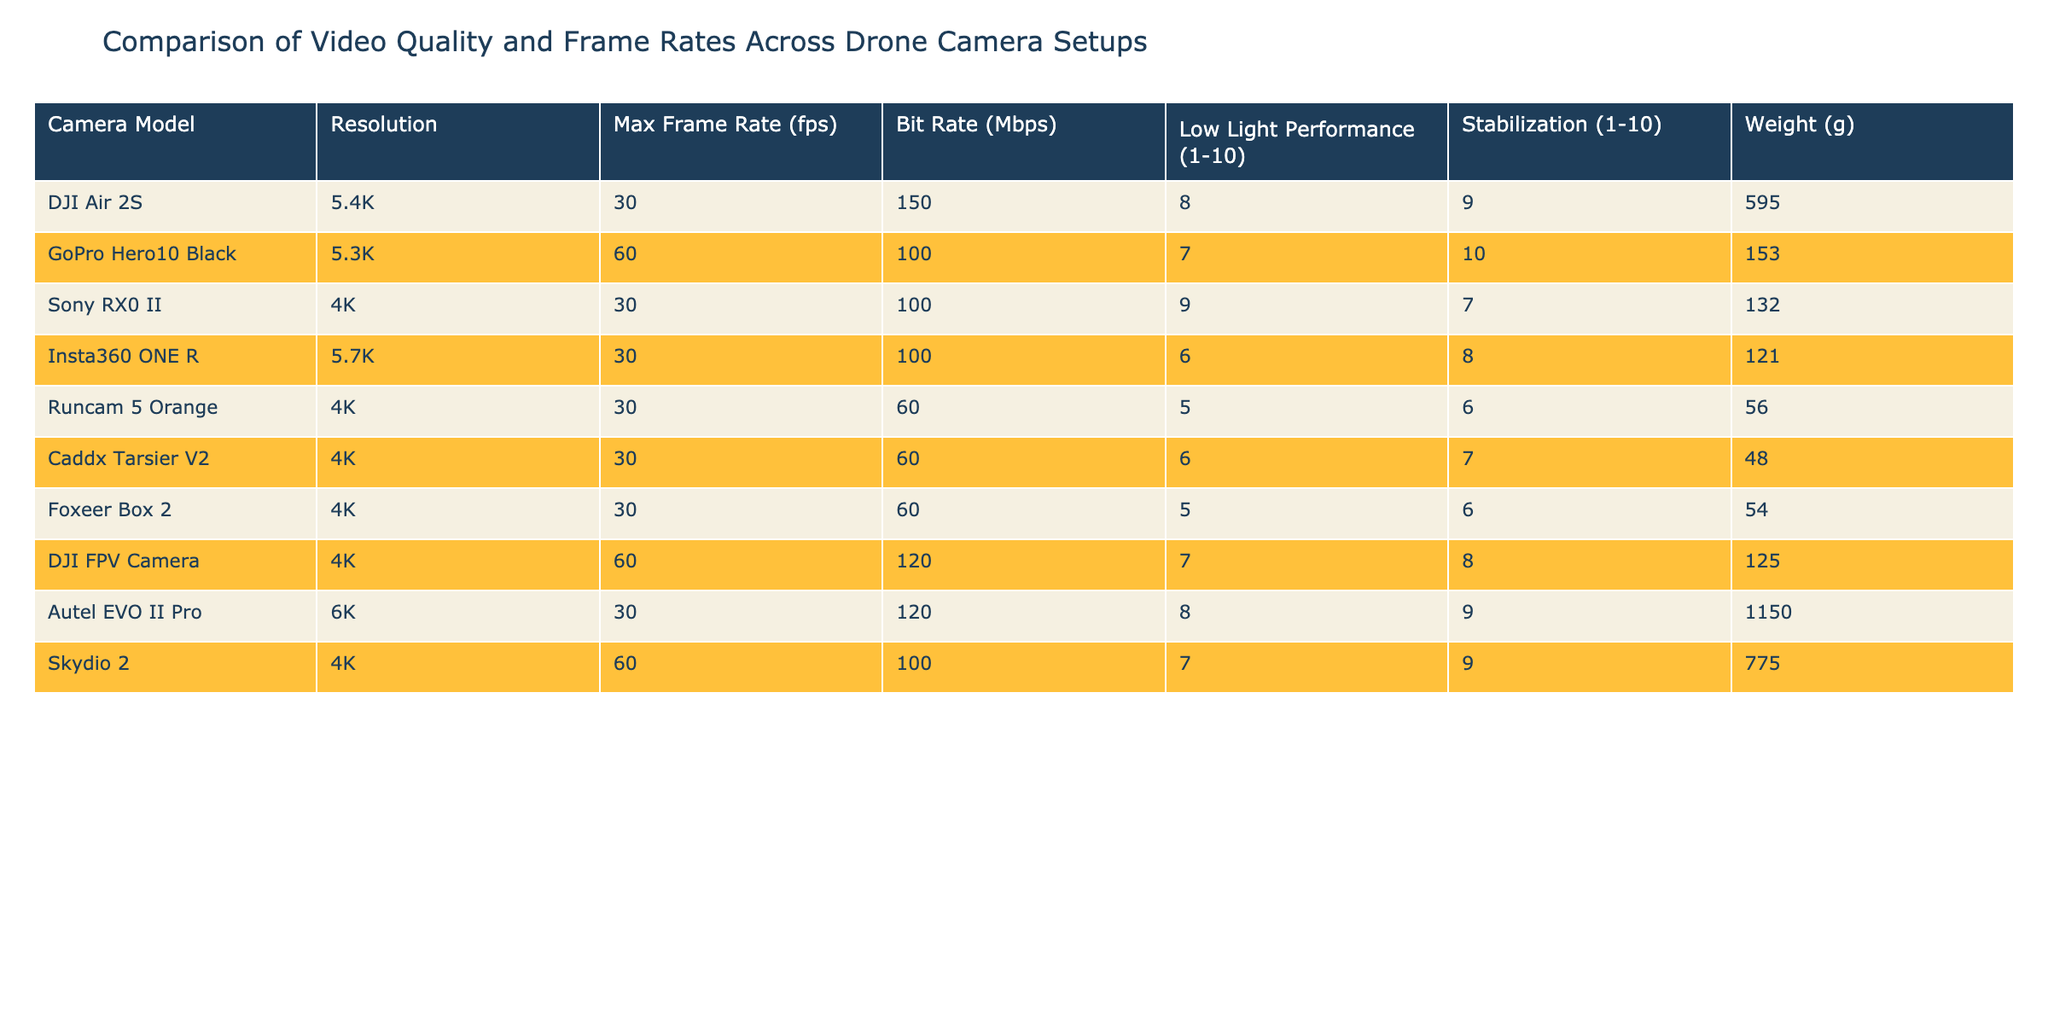What is the maximum frame rate of the DJI Air 2S? The table shows that the maximum frame rate of the DJI Air 2S is listed as 30 fps.
Answer: 30 fps Which camera has the highest resolution? Comparing all the cameras in the table, the Autel EVO II Pro has the highest resolution at 6K.
Answer: 6K What is the bit rate of the GoPro Hero10 Black? Referring to the table, the bit rate of the GoPro Hero10 Black is 100 Mbps.
Answer: 100 Mbps How does the low light performance of the Runcam 5 Orange compare to the Sony RX0 II? The Runcam 5 Orange has a low light performance rating of 5, while the Sony RX0 II has a rating of 9, meaning the Sony RX0 II performs better in low light conditions.
Answer: Sony RX0 II performs better What is the total weight of the DJI Air 2S and the GoPro Hero10 Black? We find the weight of the DJI Air 2S is 595 g and the GoPro Hero10 Black is 153 g. Adding these weights gives 595 + 153 = 748 g.
Answer: 748 g Which camera has the second highest stabilization rating? In the table, the GoPro Hero10 Black has a stabilization rating of 10, and the DJI Air 2S has a rating of 9. Therefore, the DJI Air 2S has the second highest stabilization rating.
Answer: DJI Air 2S Is there a camera with both a resolution of 4K and a frame rate of 60 fps? Looking at the table, the DJI FPV Camera and Skydio 2 both have a resolution of 4K and a maximum frame rate of 60 fps.
Answer: Yes What is the average bit rate of cameras with a 30 fps frame rate? The cameras with a 30 fps frame rate are DJI Air 2S, Sony RX0 II, Insta360 ONE R, Runcam 5 Orange, Caddx Tarsier V2, Foxeer Box 2, and Autel EVO II Pro. Their bit rates are 150, 100, 100, 60, 60, 60, and 120 Mbps respectively. The total is 150 + 100 + 100 + 60 + 60 + 60 + 120 = 650 Mbps. There are 7 cameras, so the average is 650 / 7 = approximately 92.86 Mbps.
Answer: Approximately 92.86 Mbps Which camera is the lightest, and what is its weight? Checking all entries, the Runcam 5 Orange is the lightest at 56 g.
Answer: 56 g What is the difference in low light performance between the Caddx Tarsier V2 and the GoPro Hero10 Black? Caddx Tarsier V2 has a low light performance rating of 6, and the GoPro Hero10 Black has a rating of 7. Therefore, the difference is 7 - 6 = 1.
Answer: 1 